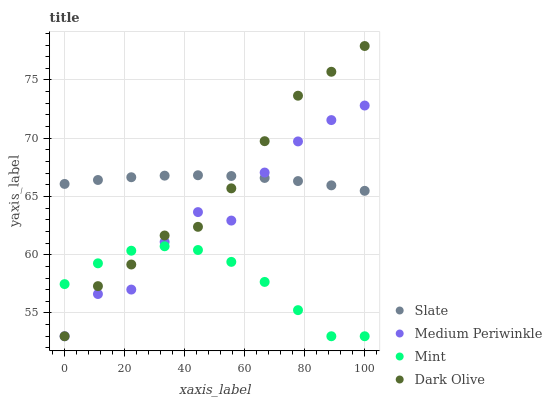Does Mint have the minimum area under the curve?
Answer yes or no. Yes. Does Slate have the maximum area under the curve?
Answer yes or no. Yes. Does Dark Olive have the minimum area under the curve?
Answer yes or no. No. Does Dark Olive have the maximum area under the curve?
Answer yes or no. No. Is Slate the smoothest?
Answer yes or no. Yes. Is Medium Periwinkle the roughest?
Answer yes or no. Yes. Is Dark Olive the smoothest?
Answer yes or no. No. Is Dark Olive the roughest?
Answer yes or no. No. Does Mint have the lowest value?
Answer yes or no. Yes. Does Slate have the lowest value?
Answer yes or no. No. Does Dark Olive have the highest value?
Answer yes or no. Yes. Does Slate have the highest value?
Answer yes or no. No. Is Mint less than Slate?
Answer yes or no. Yes. Is Slate greater than Mint?
Answer yes or no. Yes. Does Mint intersect Medium Periwinkle?
Answer yes or no. Yes. Is Mint less than Medium Periwinkle?
Answer yes or no. No. Is Mint greater than Medium Periwinkle?
Answer yes or no. No. Does Mint intersect Slate?
Answer yes or no. No. 